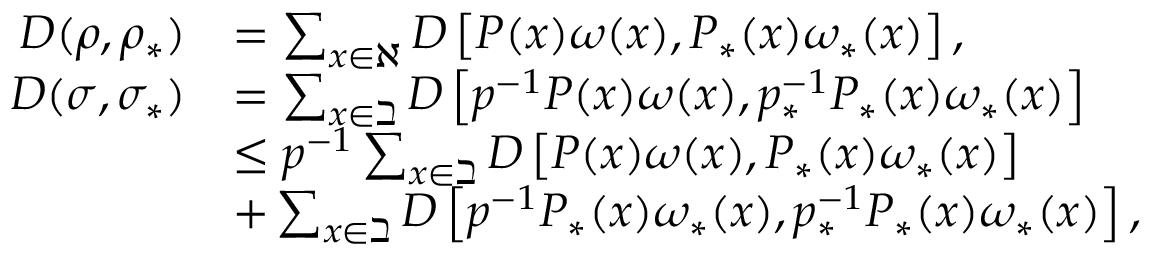Convert formula to latex. <formula><loc_0><loc_0><loc_500><loc_500>\begin{array} { r l } { D ( \rho , \rho _ { \ast } ) } & { = \sum _ { \substack { x \in \aleph } } D \left [ P ( x ) \omega ( x ) , P _ { \ast } ( x ) \omega _ { \ast } ( x ) \right ] , } \\ { D ( \sigma , \sigma _ { \ast } ) } & { = \sum _ { x \in \beth } D \left [ p ^ { - 1 } P ( x ) \omega ( x ) , p _ { \ast } ^ { - 1 } P _ { \ast } ( x ) \omega _ { \ast } ( x ) \right ] } \\ & { \leq p ^ { - 1 } \sum _ { x \in \beth } D \left [ P ( x ) \omega ( x ) , P _ { \ast } ( x ) \omega _ { \ast } ( x ) \right ] } \\ & { + \sum _ { x \in \beth } D \left [ p ^ { - 1 } P _ { \ast } ( x ) \omega _ { \ast } ( x ) , p _ { \ast } ^ { - 1 } P _ { \ast } ( x ) \omega _ { \ast } ( x ) \right ] , } \end{array}</formula> 